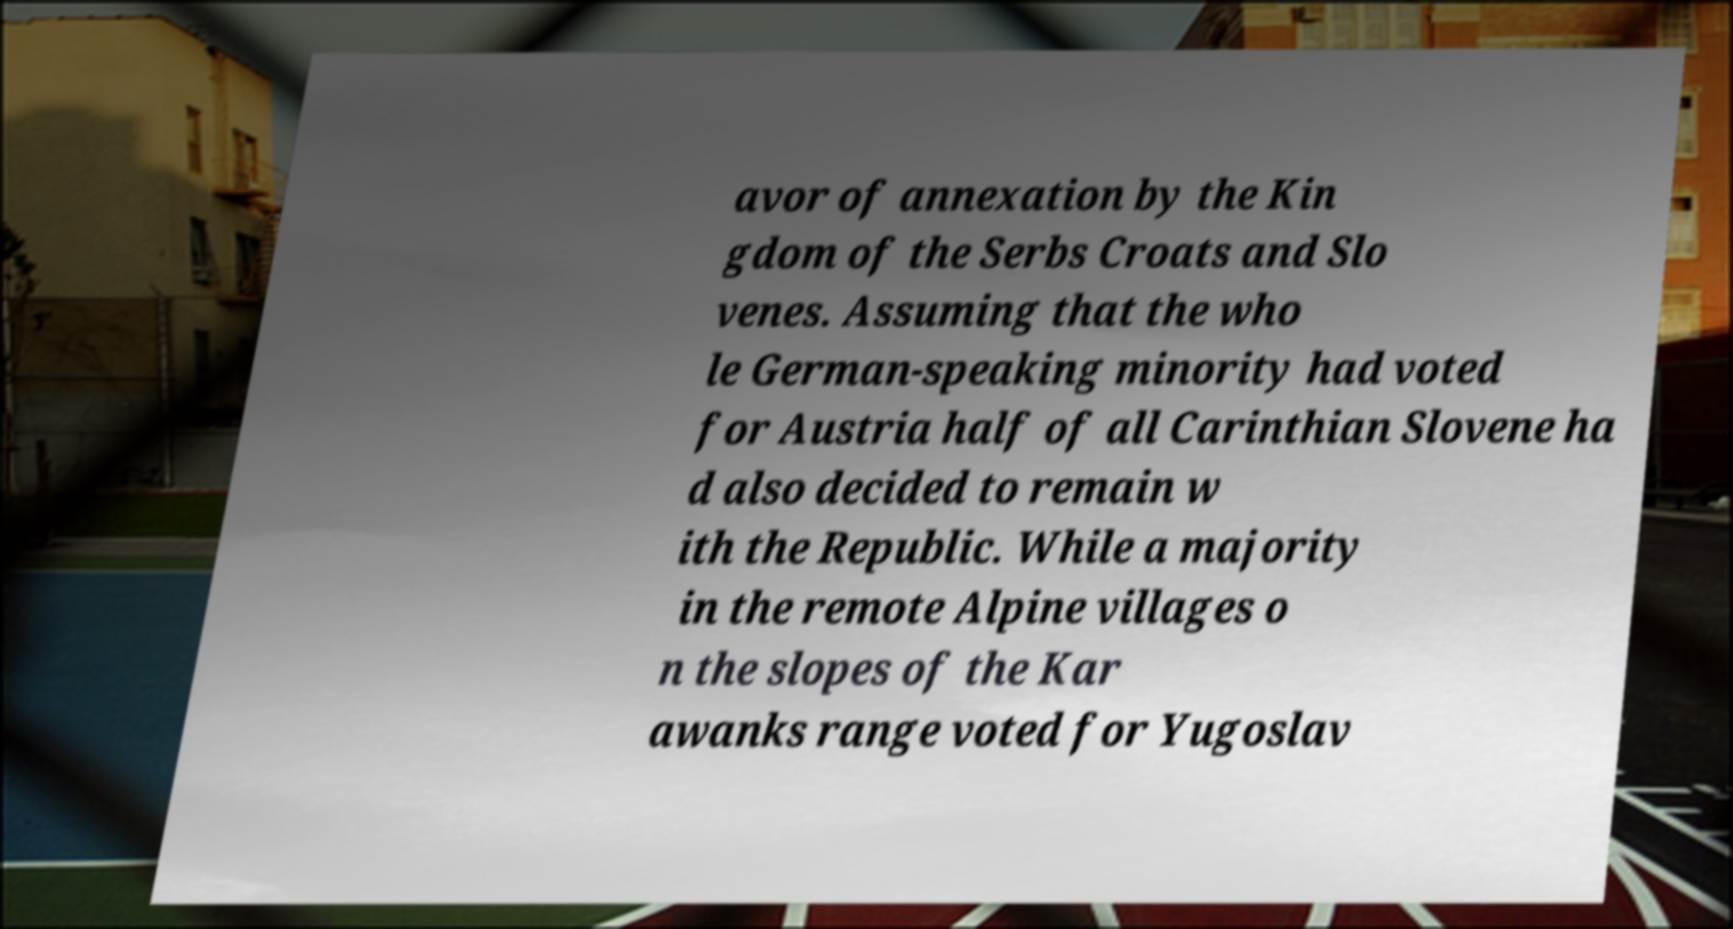Could you assist in decoding the text presented in this image and type it out clearly? avor of annexation by the Kin gdom of the Serbs Croats and Slo venes. Assuming that the who le German-speaking minority had voted for Austria half of all Carinthian Slovene ha d also decided to remain w ith the Republic. While a majority in the remote Alpine villages o n the slopes of the Kar awanks range voted for Yugoslav 